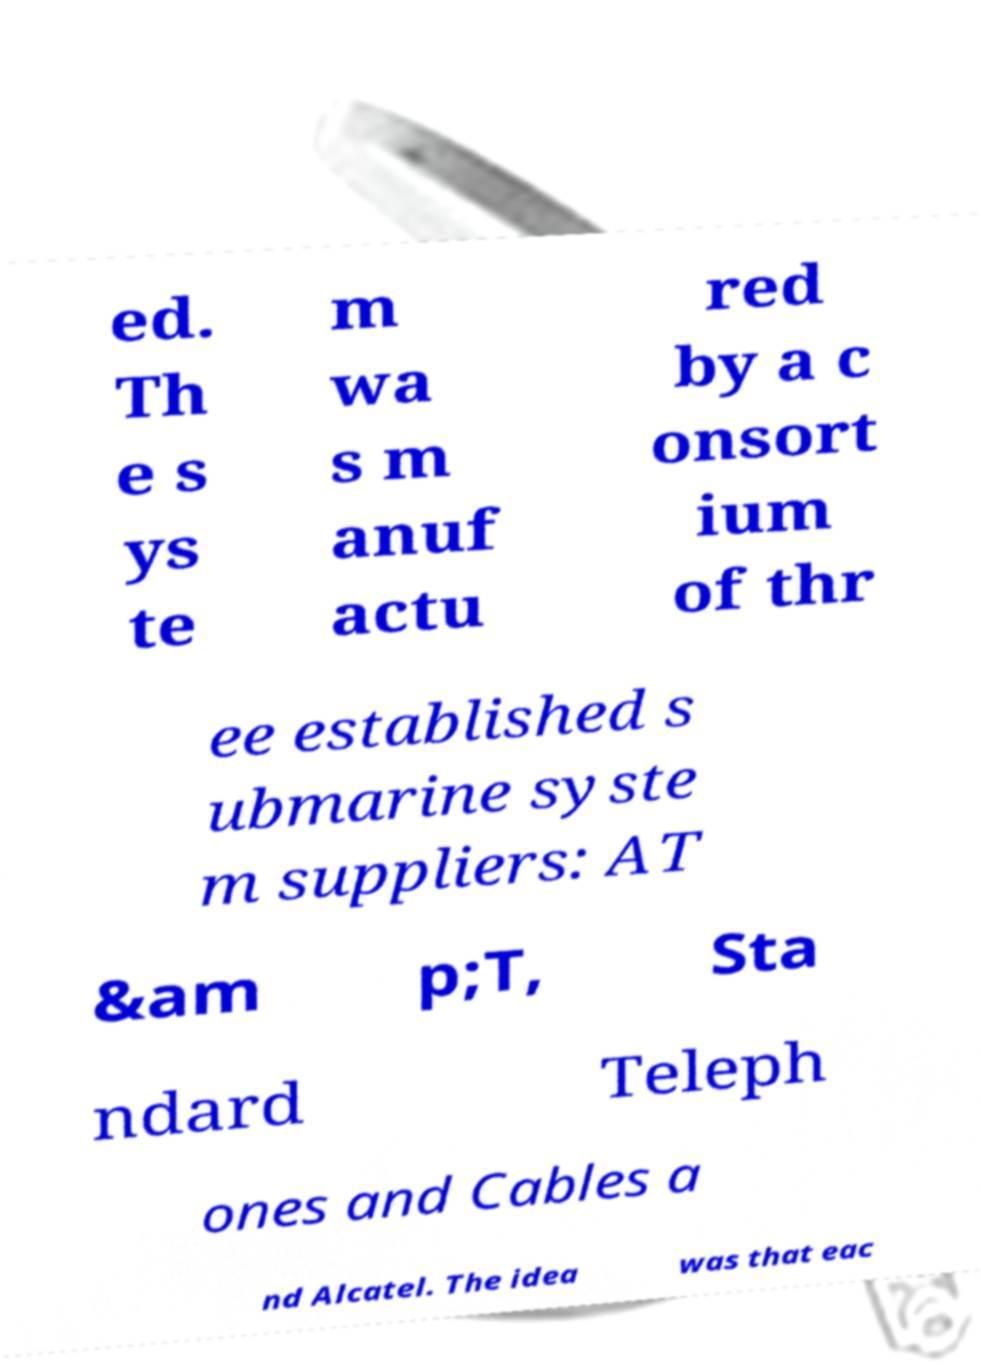Can you read and provide the text displayed in the image?This photo seems to have some interesting text. Can you extract and type it out for me? ed. Th e s ys te m wa s m anuf actu red by a c onsort ium of thr ee established s ubmarine syste m suppliers: AT &am p;T, Sta ndard Teleph ones and Cables a nd Alcatel. The idea was that eac 